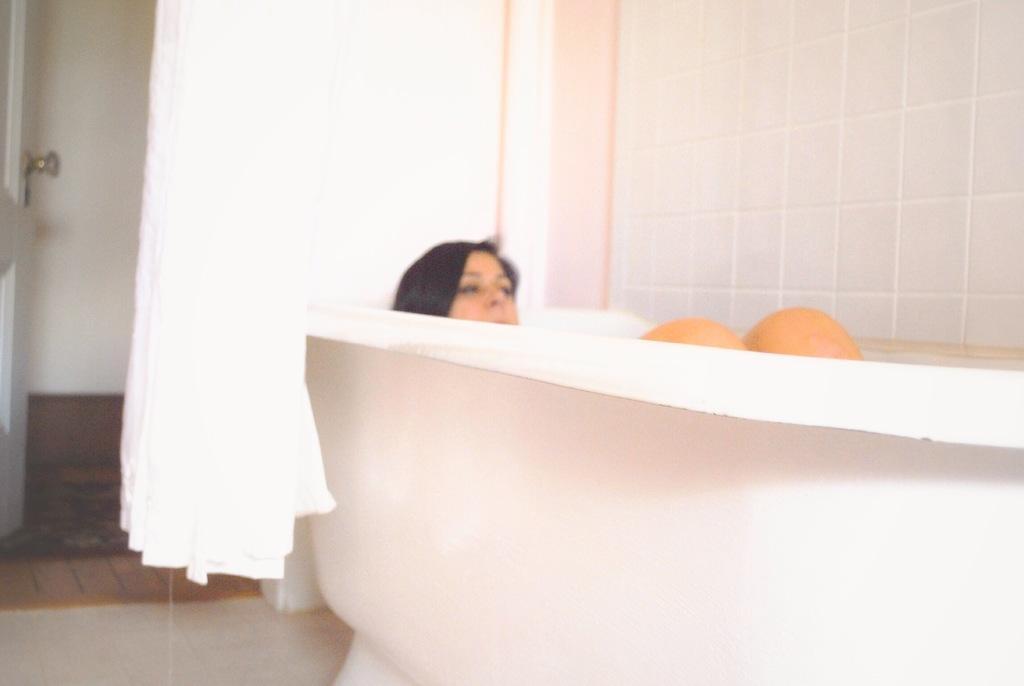Could you give a brief overview of what you see in this image? Here a woman is bathing in a bathtub. In the middle it is a curtain. 